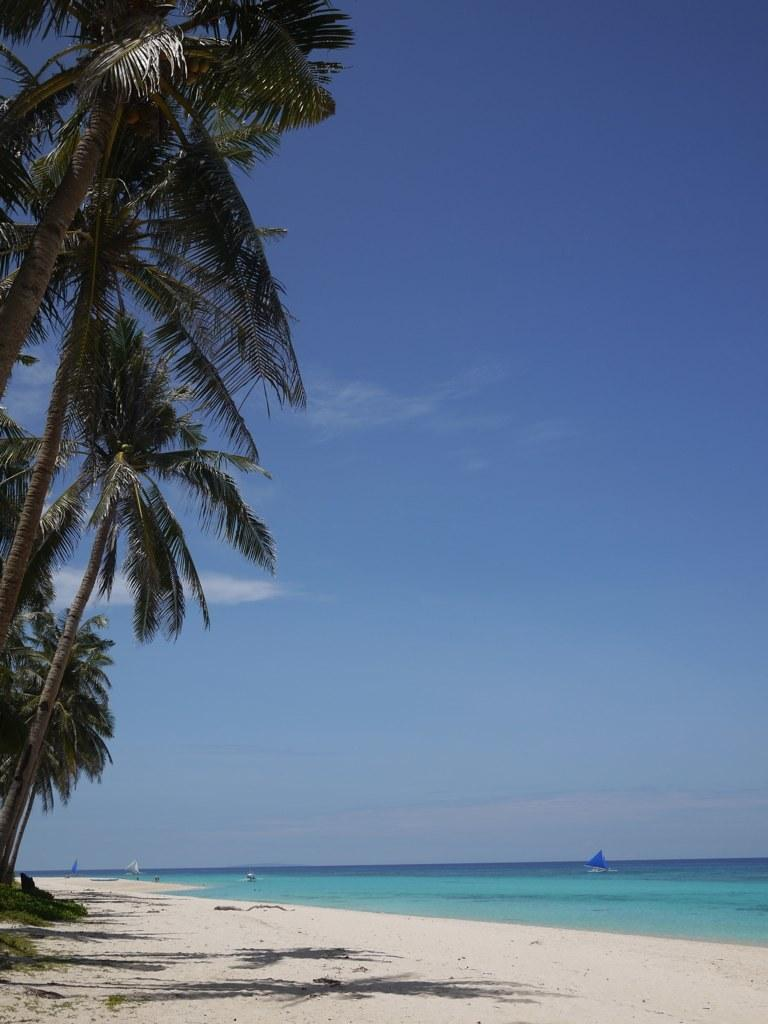What type of vegetation is on the left side of the image? There are trees on the left side of the image. What natural feature can be seen on the right side of the image? There appears to be a sea on the right side of the image. What is visible at the top of the image? The sky is visible at the top of the image. How many feathers are scattered on the ground in the image? There are no feathers present in the image. 